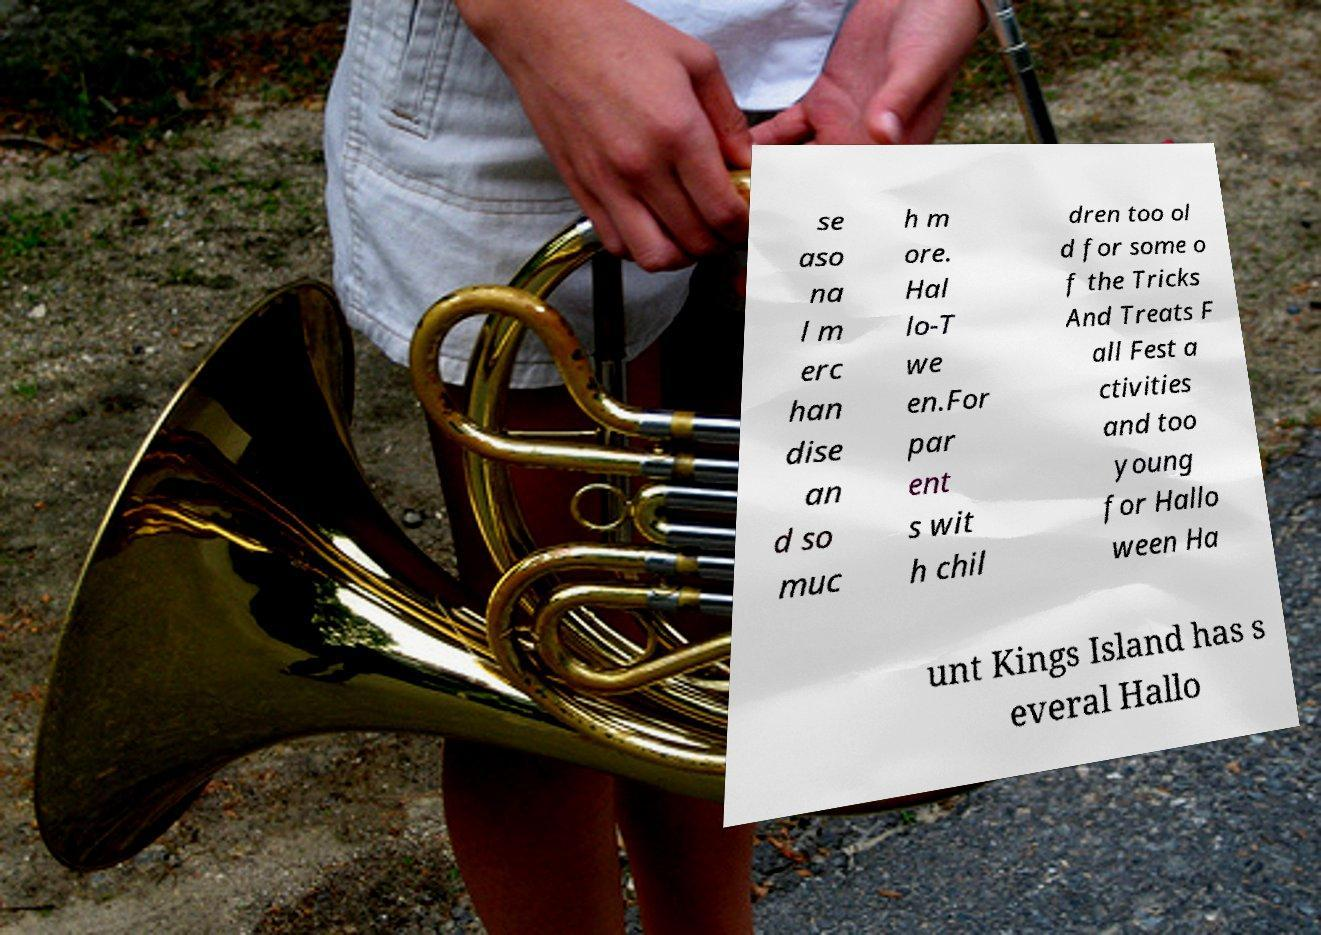I need the written content from this picture converted into text. Can you do that? se aso na l m erc han dise an d so muc h m ore. Hal lo-T we en.For par ent s wit h chil dren too ol d for some o f the Tricks And Treats F all Fest a ctivities and too young for Hallo ween Ha unt Kings Island has s everal Hallo 